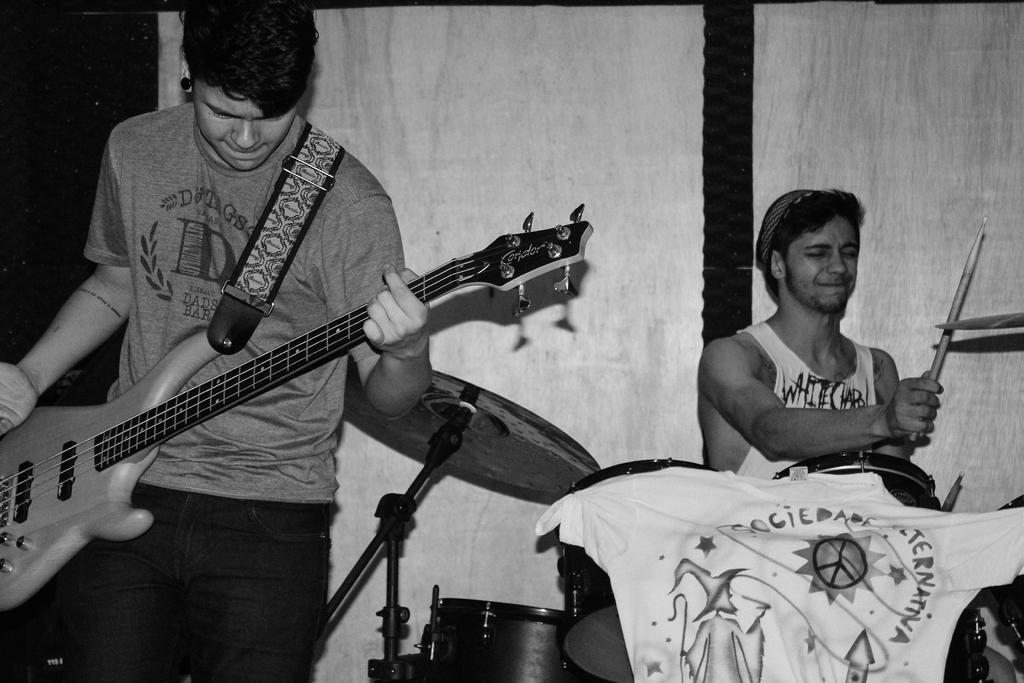Can you describe this image briefly? In this image I can see two men. one man is sitting and playing the drums on the right side of the image. A man who is on the left side is standing and holding a guitar in his hands. 